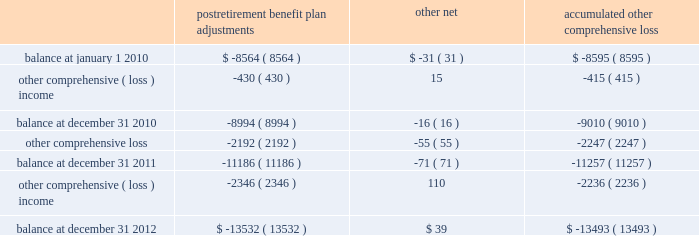Until the hedged transaction is recognized in earnings .
Changes in the fair value of the derivatives that are attributable to the ineffective portion of the hedges , or of derivatives that are not considered to be highly effective hedges , if any , are immediately recognized in earnings .
The aggregate notional amount of our outstanding foreign currency hedges at december 31 , 2012 and 2011 was $ 1.3 billion and $ 1.7 billion .
The aggregate notional amount of our outstanding interest rate swaps at december 31 , 2012 and 2011 was $ 503 million and $ 450 million .
Derivative instruments did not have a material impact on net earnings and comprehensive income during 2012 , 2011 , and 2010 .
Substantially all of our derivatives are designated for hedge accounting .
See note 15 for more information on the fair value measurements related to our derivative instruments .
Stock-based compensation 2013 compensation cost related to all share-based payments including stock options and restricted stock units is measured at the grant date based on the estimated fair value of the award .
We generally recognize the compensation cost ratably over a three-year vesting period .
Income taxes 2013 we periodically assess our tax filing exposures related to periods that are open to examination .
Based on the latest available information , we evaluate our tax positions to determine whether the position will more likely than not be sustained upon examination by the internal revenue service ( irs ) .
If we cannot reach a more-likely-than-not determination , no benefit is recorded .
If we determine that the tax position is more likely than not to be sustained , we record the largest amount of benefit that is more likely than not to be realized when the tax position is settled .
We record interest and penalties related to income taxes as a component of income tax expense on our statements of earnings .
Interest and penalties are not material .
Accumulated other comprehensive loss 2013 changes in the balance of accumulated other comprehensive loss , net of income taxes , consisted of the following ( in millions ) : postretirement benefit plan adjustments other , net accumulated comprehensive .
The postretirement benefit plan adjustments are shown net of tax benefits at december 31 , 2012 , 2011 , and 2010 of $ 7.4 billion , $ 6.1 billion , and $ 4.9 billion .
These tax benefits include amounts recognized on our income tax returns as current deductions and deferred income taxes , which will be recognized on our tax returns in future years .
See note 7 and note 9 for more information on our income taxes and postretirement plans .
Recent accounting pronouncements 2013 effective january 1 , 2012 , we retrospectively adopted new guidance issued by the financial accounting standards board by presenting total comprehensive income and the components of net income and other comprehensive loss in two separate but consecutive statements .
The adoption of this guidance resulted only in a change in how we present other comprehensive loss in our consolidated financial statements and did not have any impact on our results of operations , financial position , or cash flows. .
What is the percentage change in aggregate notional amount of outstanding foreign currency hedges from 2011 to 2012? 
Computations: ((1.3 - 1.7) / 1.7)
Answer: -0.23529. 